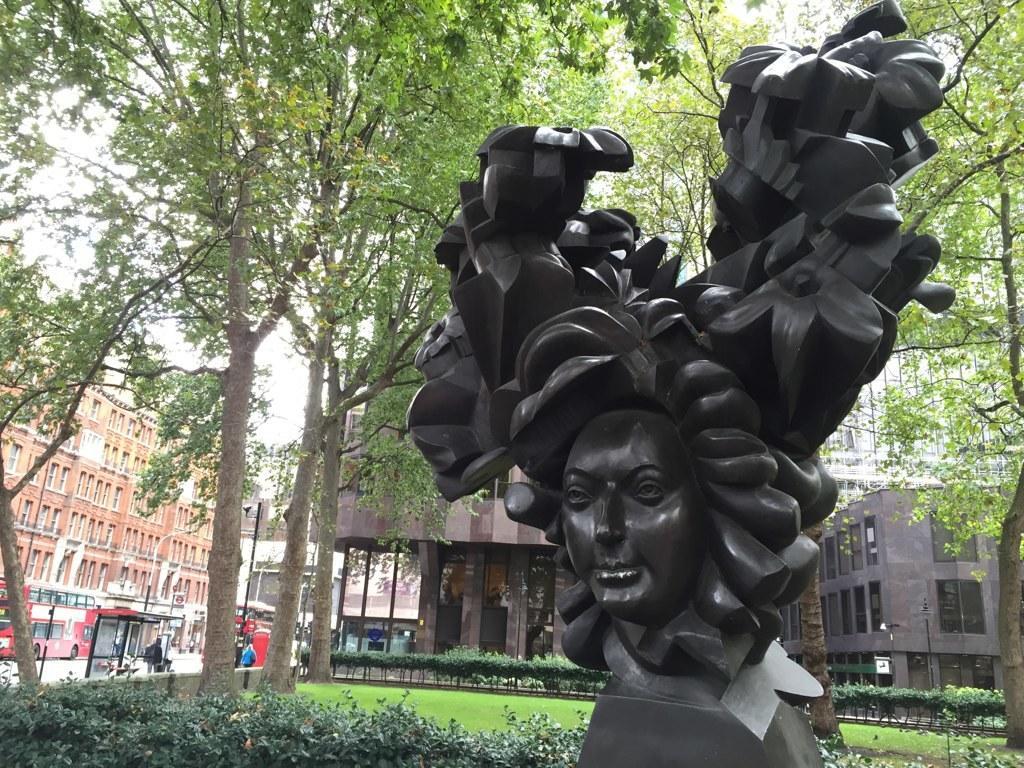Describe this image in one or two sentences. On the right side of the image, we can see a statue. In the background, there are plants, grass, trees, buildings, walls, glass objects, poles, boards, people, vehicles, road and the sky. 